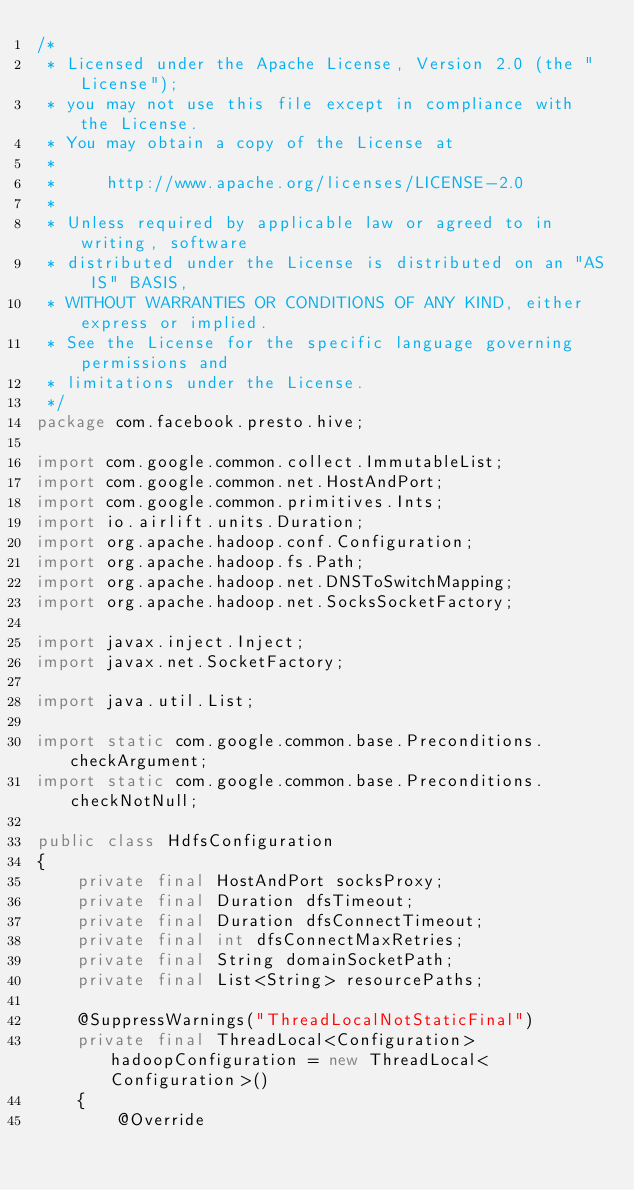Convert code to text. <code><loc_0><loc_0><loc_500><loc_500><_Java_>/*
 * Licensed under the Apache License, Version 2.0 (the "License");
 * you may not use this file except in compliance with the License.
 * You may obtain a copy of the License at
 *
 *     http://www.apache.org/licenses/LICENSE-2.0
 *
 * Unless required by applicable law or agreed to in writing, software
 * distributed under the License is distributed on an "AS IS" BASIS,
 * WITHOUT WARRANTIES OR CONDITIONS OF ANY KIND, either express or implied.
 * See the License for the specific language governing permissions and
 * limitations under the License.
 */
package com.facebook.presto.hive;

import com.google.common.collect.ImmutableList;
import com.google.common.net.HostAndPort;
import com.google.common.primitives.Ints;
import io.airlift.units.Duration;
import org.apache.hadoop.conf.Configuration;
import org.apache.hadoop.fs.Path;
import org.apache.hadoop.net.DNSToSwitchMapping;
import org.apache.hadoop.net.SocksSocketFactory;

import javax.inject.Inject;
import javax.net.SocketFactory;

import java.util.List;

import static com.google.common.base.Preconditions.checkArgument;
import static com.google.common.base.Preconditions.checkNotNull;

public class HdfsConfiguration
{
    private final HostAndPort socksProxy;
    private final Duration dfsTimeout;
    private final Duration dfsConnectTimeout;
    private final int dfsConnectMaxRetries;
    private final String domainSocketPath;
    private final List<String> resourcePaths;

    @SuppressWarnings("ThreadLocalNotStaticFinal")
    private final ThreadLocal<Configuration> hadoopConfiguration = new ThreadLocal<Configuration>()
    {
        @Override</code> 